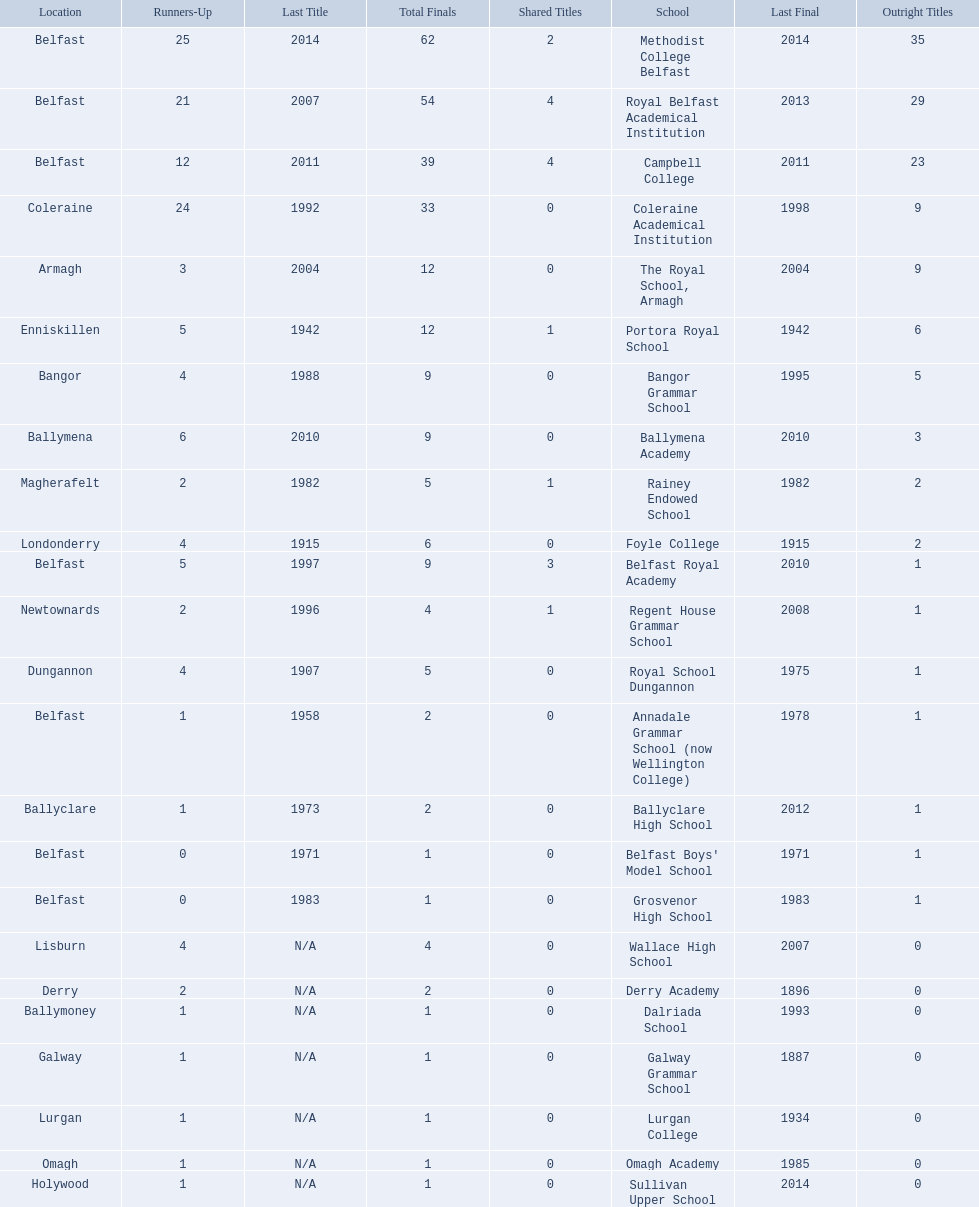Which colleges participated in the ulster's schools' cup? Methodist College Belfast, Royal Belfast Academical Institution, Campbell College, Coleraine Academical Institution, The Royal School, Armagh, Portora Royal School, Bangor Grammar School, Ballymena Academy, Rainey Endowed School, Foyle College, Belfast Royal Academy, Regent House Grammar School, Royal School Dungannon, Annadale Grammar School (now Wellington College), Ballyclare High School, Belfast Boys' Model School, Grosvenor High School, Wallace High School, Derry Academy, Dalriada School, Galway Grammar School, Lurgan College, Omagh Academy, Sullivan Upper School. Of these, which are from belfast? Methodist College Belfast, Royal Belfast Academical Institution, Campbell College, Belfast Royal Academy, Annadale Grammar School (now Wellington College), Belfast Boys' Model School, Grosvenor High School. Of these, which have more than 20 outright titles? Methodist College Belfast, Royal Belfast Academical Institution, Campbell College. Which of these have the fewest runners-up? Campbell College. 